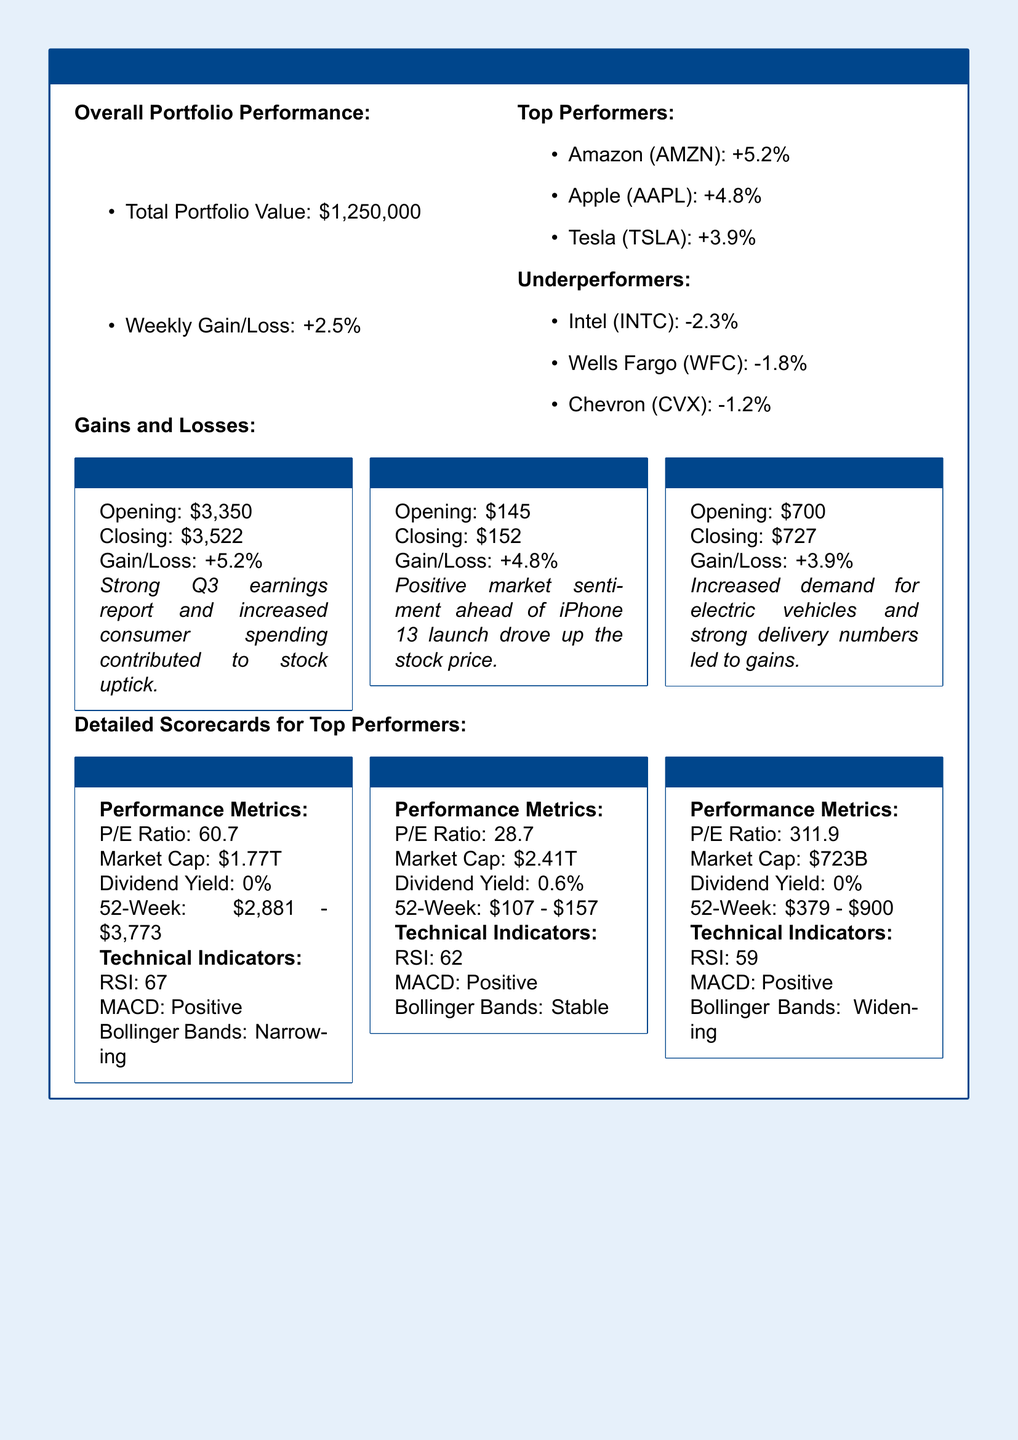What is the total portfolio value? The total portfolio value is stated in the document as $1,250,000.
Answer: $1,250,000 What was the weekly gain/loss percentage? The document indicates the weekly gain/loss percentage is +2.5%.
Answer: +2.5% Which stock had the highest weekly gain? The stock with the highest weekly gain is mentioned as Amazon (AMZN) with +5.2%.
Answer: Amazon (AMZN) What is the P/E ratio of Apple (AAPL)? The document states the P/E ratio of Apple (AAPL) is 28.7.
Answer: 28.7 Which company experienced the largest loss? The document states that Intel (INTC) experienced the largest loss of -2.3%.
Answer: Intel (INTC) What was Tesla's closing price? The closing price of Tesla (TSLA) is provided as $727.
Answer: $727 How much is the dividend yield for Apple (AAPL)? The dividend yield for Apple (AAPL) is noted as 0.6%.
Answer: 0.6% What does RSI stand for in the context of stock performance? The acronym RSI stands for Relative Strength Index, indicated in the technical indicators section.
Answer: Relative Strength Index Which stock had a market cap of $2.41 trillion? The document mentions that Apple (AAPL) had a market cap of $2.41 trillion.
Answer: Apple (AAPL) 